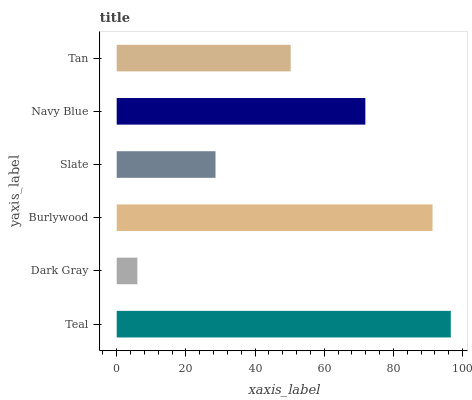Is Dark Gray the minimum?
Answer yes or no. Yes. Is Teal the maximum?
Answer yes or no. Yes. Is Burlywood the minimum?
Answer yes or no. No. Is Burlywood the maximum?
Answer yes or no. No. Is Burlywood greater than Dark Gray?
Answer yes or no. Yes. Is Dark Gray less than Burlywood?
Answer yes or no. Yes. Is Dark Gray greater than Burlywood?
Answer yes or no. No. Is Burlywood less than Dark Gray?
Answer yes or no. No. Is Navy Blue the high median?
Answer yes or no. Yes. Is Tan the low median?
Answer yes or no. Yes. Is Burlywood the high median?
Answer yes or no. No. Is Dark Gray the low median?
Answer yes or no. No. 